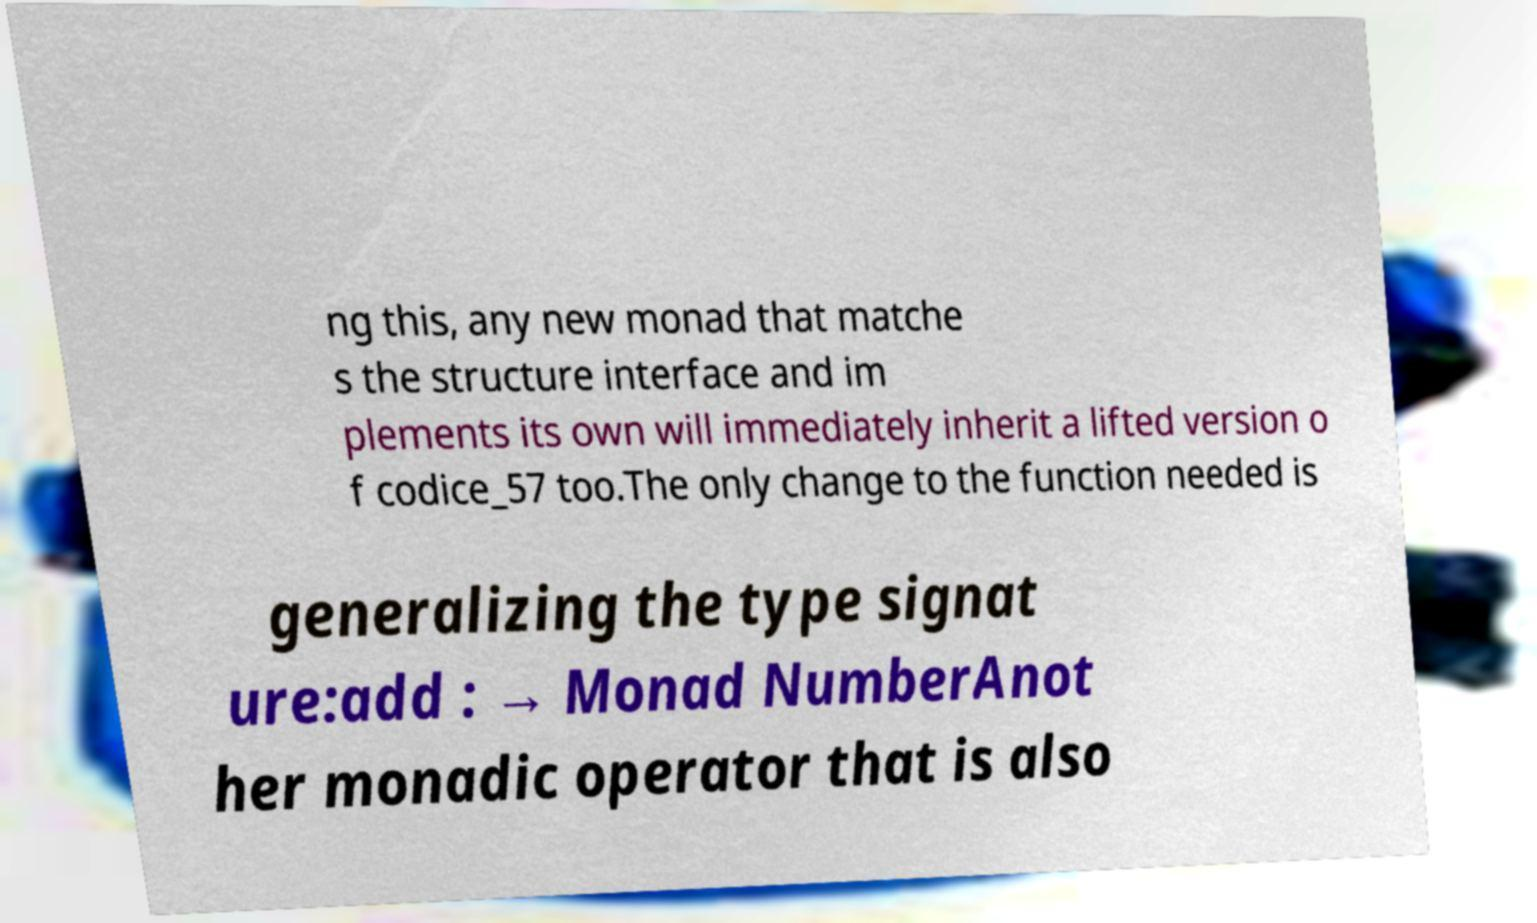Can you accurately transcribe the text from the provided image for me? ng this, any new monad that matche s the structure interface and im plements its own will immediately inherit a lifted version o f codice_57 too.The only change to the function needed is generalizing the type signat ure:add : → Monad NumberAnot her monadic operator that is also 